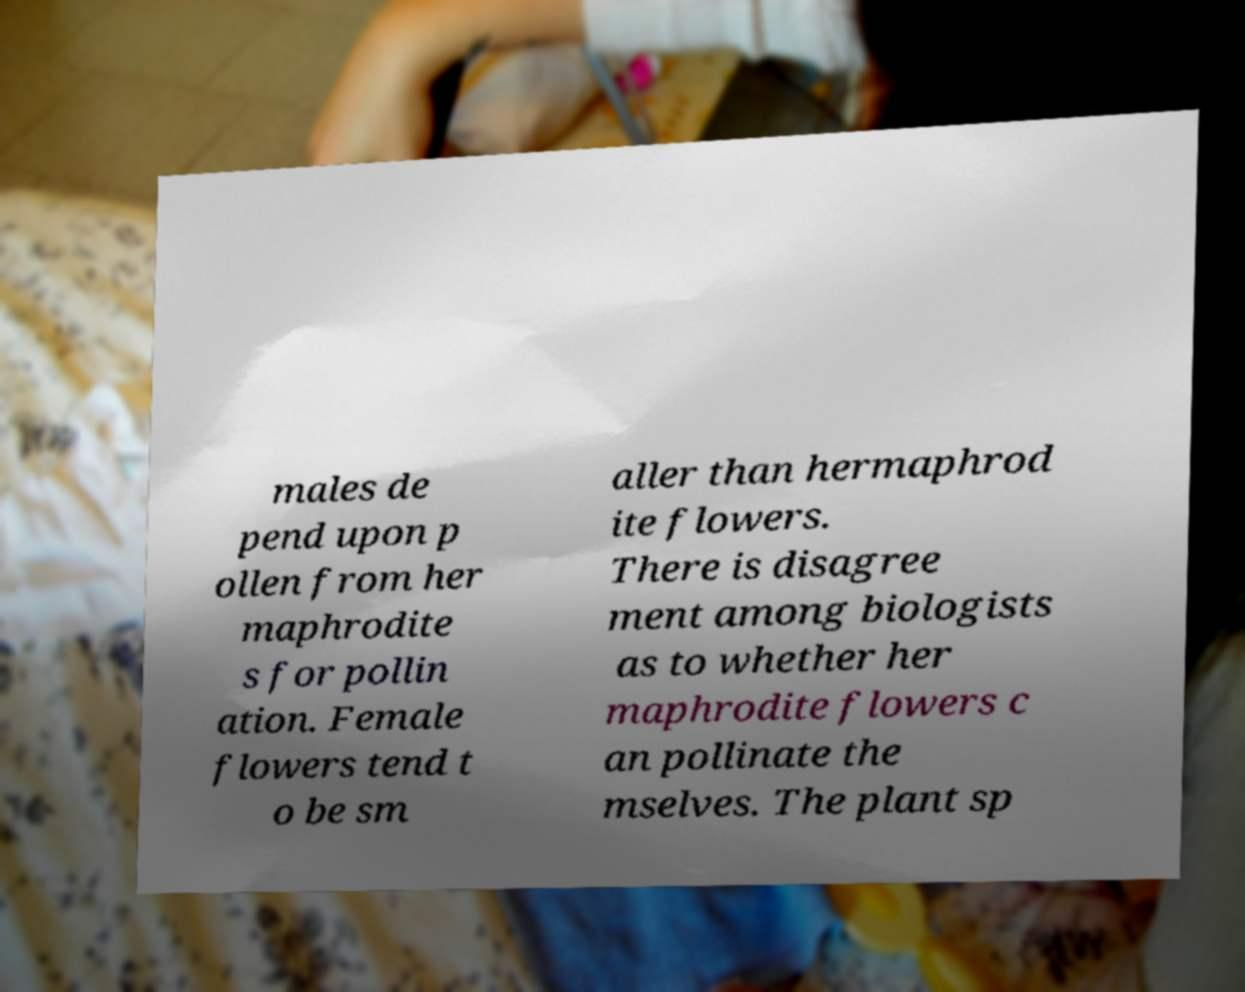Please identify and transcribe the text found in this image. males de pend upon p ollen from her maphrodite s for pollin ation. Female flowers tend t o be sm aller than hermaphrod ite flowers. There is disagree ment among biologists as to whether her maphrodite flowers c an pollinate the mselves. The plant sp 